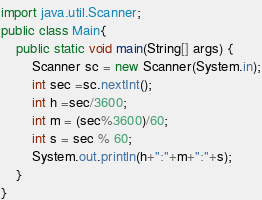Convert code to text. <code><loc_0><loc_0><loc_500><loc_500><_Java_>import java.util.Scanner;
public class Main{
    public static void main(String[] args) {
	    Scanner sc = new Scanner(System.in);
        int sec =sc.nextInt();
        int h =sec/3600;
        int m = (sec%3600)/60;
        int s = sec % 60;
        System.out.println(h+":"+m+":"+s);
	}
}
</code> 